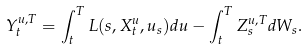<formula> <loc_0><loc_0><loc_500><loc_500>Y ^ { u , T } _ { t } = \int _ { t } ^ { T } L ( s , X ^ { u } _ { t } , u _ { s } ) d u - \int _ { t } ^ { T } Z ^ { u , T } _ { s } d W _ { s } .</formula> 